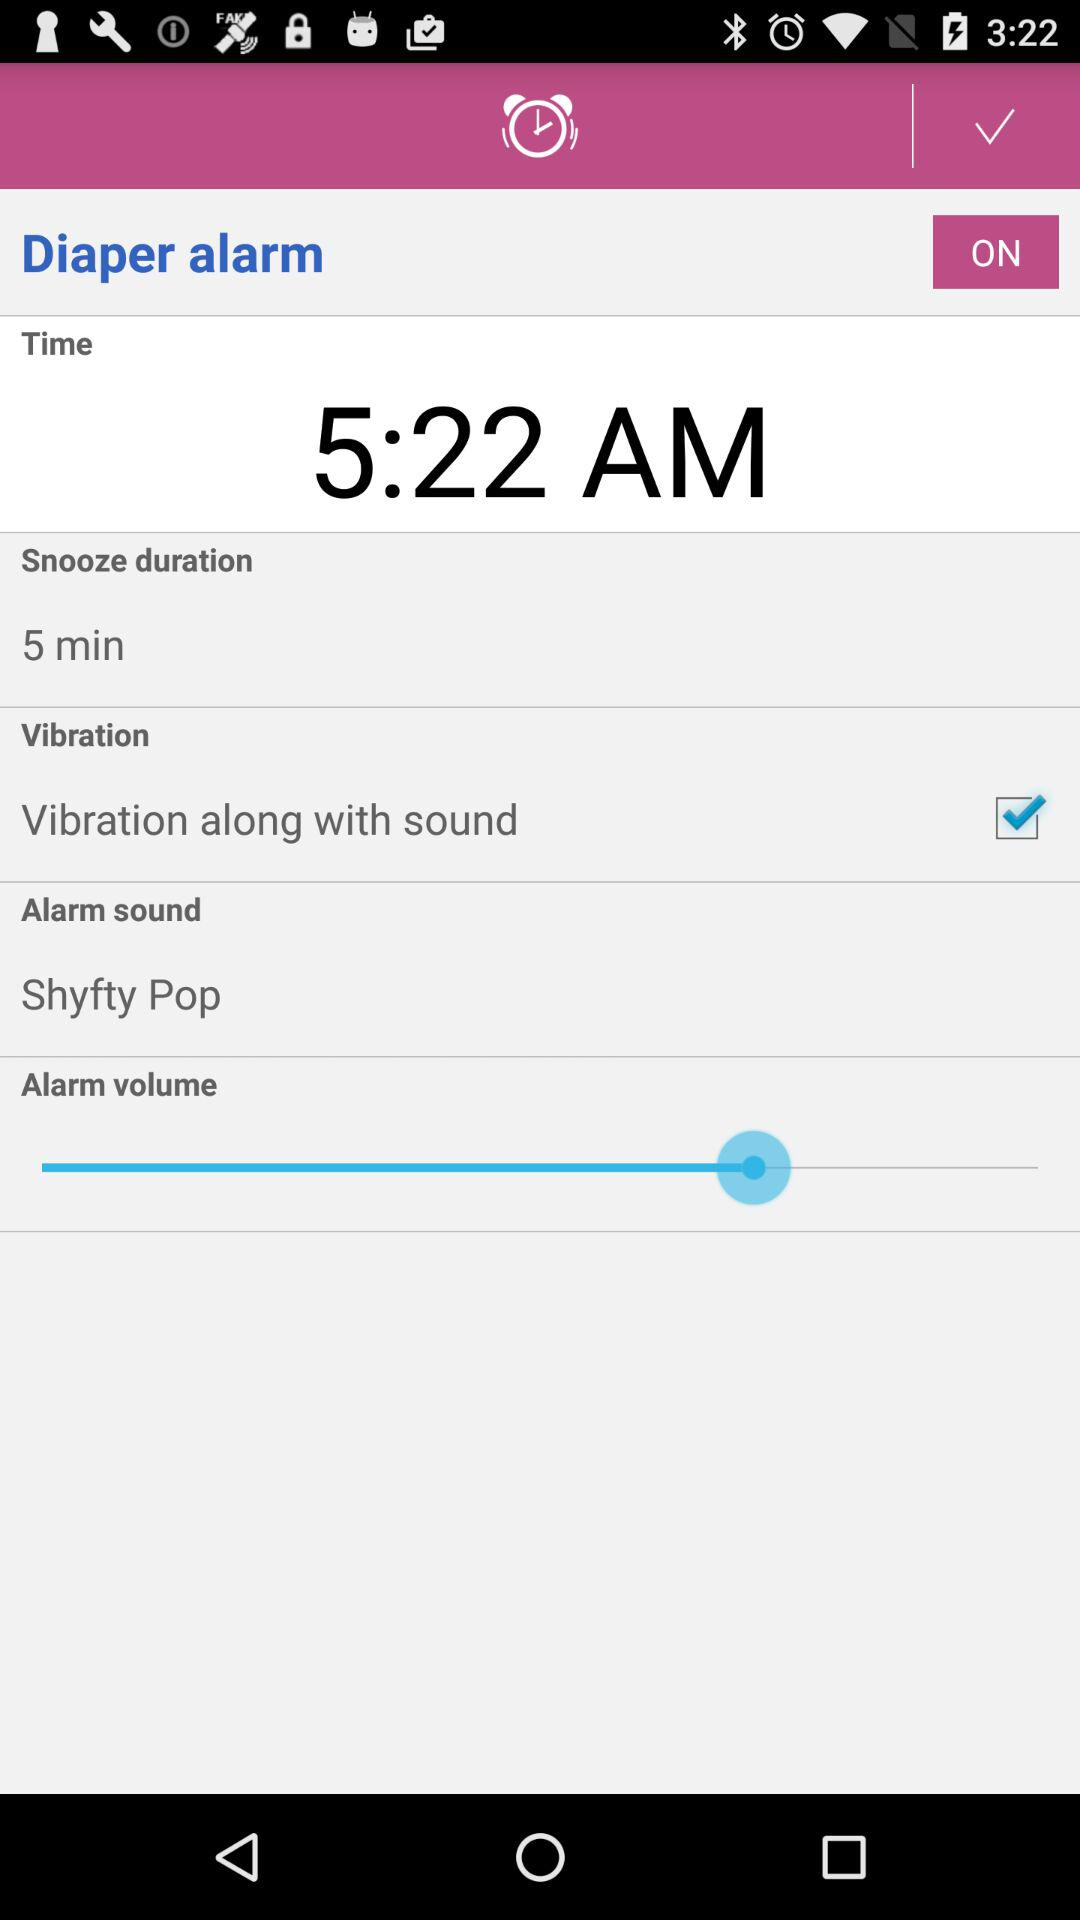What is the snooze duration? The snooze duration is 5 minutes. 